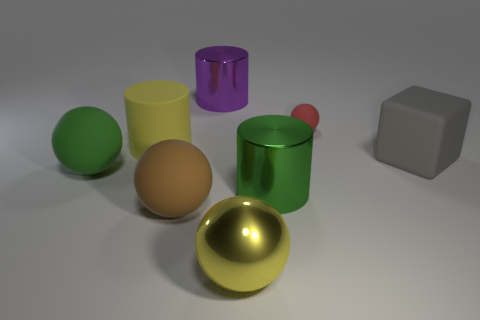Subtract all metal cylinders. How many cylinders are left? 1 Add 2 purple metal things. How many objects exist? 10 Subtract all cylinders. How many objects are left? 5 Subtract 2 cylinders. How many cylinders are left? 1 Add 5 brown rubber things. How many brown rubber things are left? 6 Add 1 tiny brown metallic cubes. How many tiny brown metallic cubes exist? 1 Subtract all red balls. How many balls are left? 3 Subtract 0 red cylinders. How many objects are left? 8 Subtract all red blocks. Subtract all red spheres. How many blocks are left? 1 Subtract all rubber objects. Subtract all blocks. How many objects are left? 2 